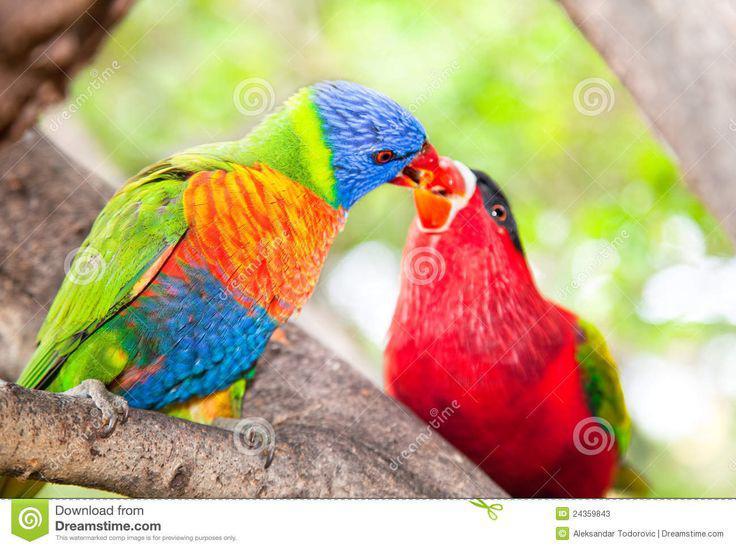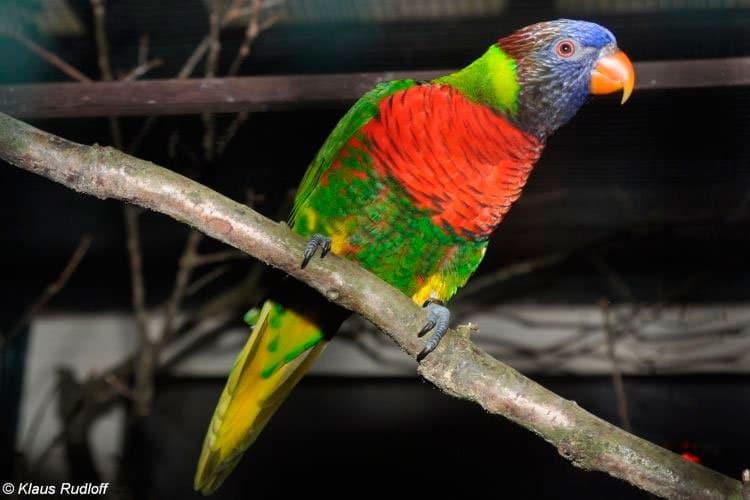The first image is the image on the left, the second image is the image on the right. For the images shown, is this caption "Exactly two parrots are sitting on tree branches, both of them having at least some green on their bodies, but only one with a blue head." true? Answer yes or no. No. The first image is the image on the left, the second image is the image on the right. Analyze the images presented: Is the assertion "The left image shows exactly one parrot, and it is perched on a wooden limb." valid? Answer yes or no. No. 